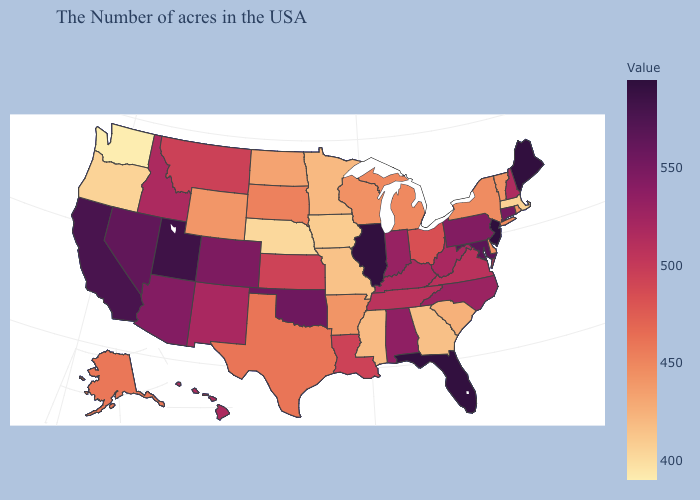Which states hav the highest value in the West?
Keep it brief. Utah. Does Florida have the highest value in the South?
Write a very short answer. Yes. Which states hav the highest value in the West?
Short answer required. Utah. Which states hav the highest value in the South?
Quick response, please. Florida. Which states have the lowest value in the Northeast?
Concise answer only. Massachusetts. Does Kentucky have a lower value than Arizona?
Give a very brief answer. Yes. Among the states that border Missouri , which have the lowest value?
Short answer required. Nebraska. Which states have the lowest value in the South?
Be succinct. Georgia. 